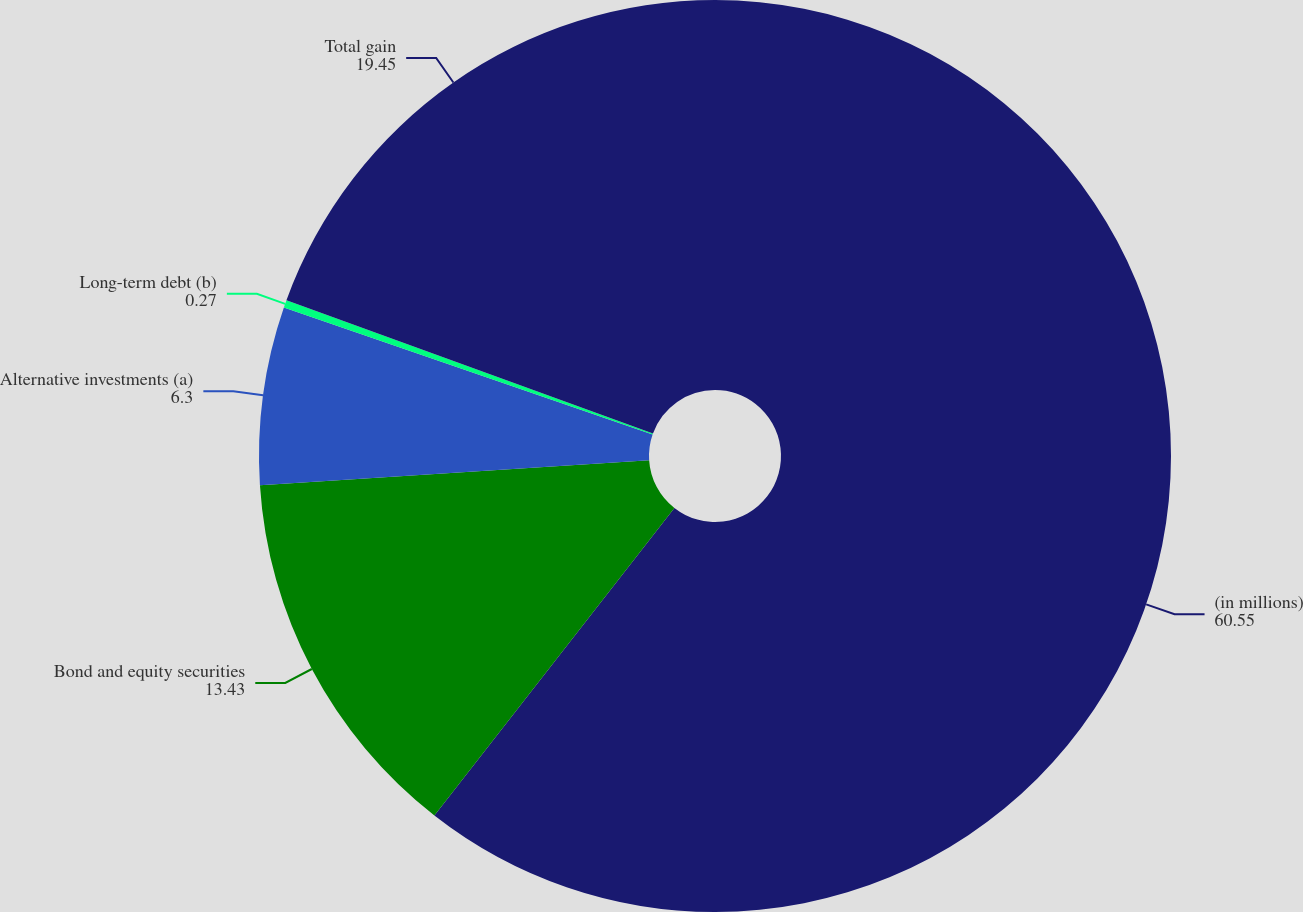<chart> <loc_0><loc_0><loc_500><loc_500><pie_chart><fcel>(in millions)<fcel>Bond and equity securities<fcel>Alternative investments (a)<fcel>Long-term debt (b)<fcel>Total gain<nl><fcel>60.55%<fcel>13.43%<fcel>6.3%<fcel>0.27%<fcel>19.45%<nl></chart> 